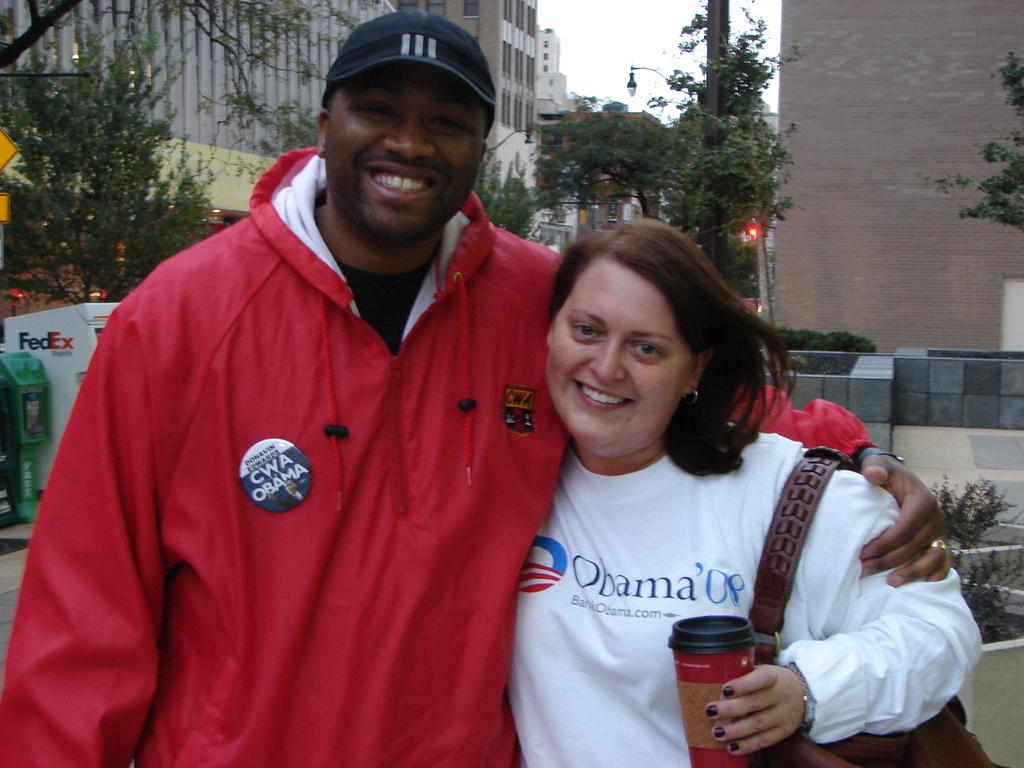<image>
Relay a brief, clear account of the picture shown. The man is wearing a badge with Donavin Edwards CWA OBAMA and lady has a BankObama.com shirt on. 